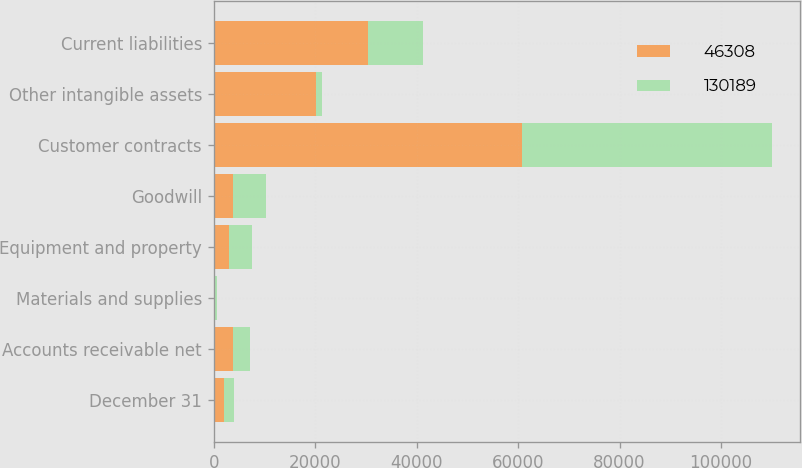Convert chart. <chart><loc_0><loc_0><loc_500><loc_500><stacked_bar_chart><ecel><fcel>December 31<fcel>Accounts receivable net<fcel>Materials and supplies<fcel>Equipment and property<fcel>Goodwill<fcel>Customer contracts<fcel>Other intangible assets<fcel>Current liabilities<nl><fcel>46308<fcel>2017<fcel>3836<fcel>312<fcel>3027<fcel>3836<fcel>60695<fcel>20086<fcel>30344<nl><fcel>130189<fcel>2016<fcel>3334<fcel>353<fcel>4525<fcel>6468<fcel>49365<fcel>1285<fcel>10809<nl></chart> 